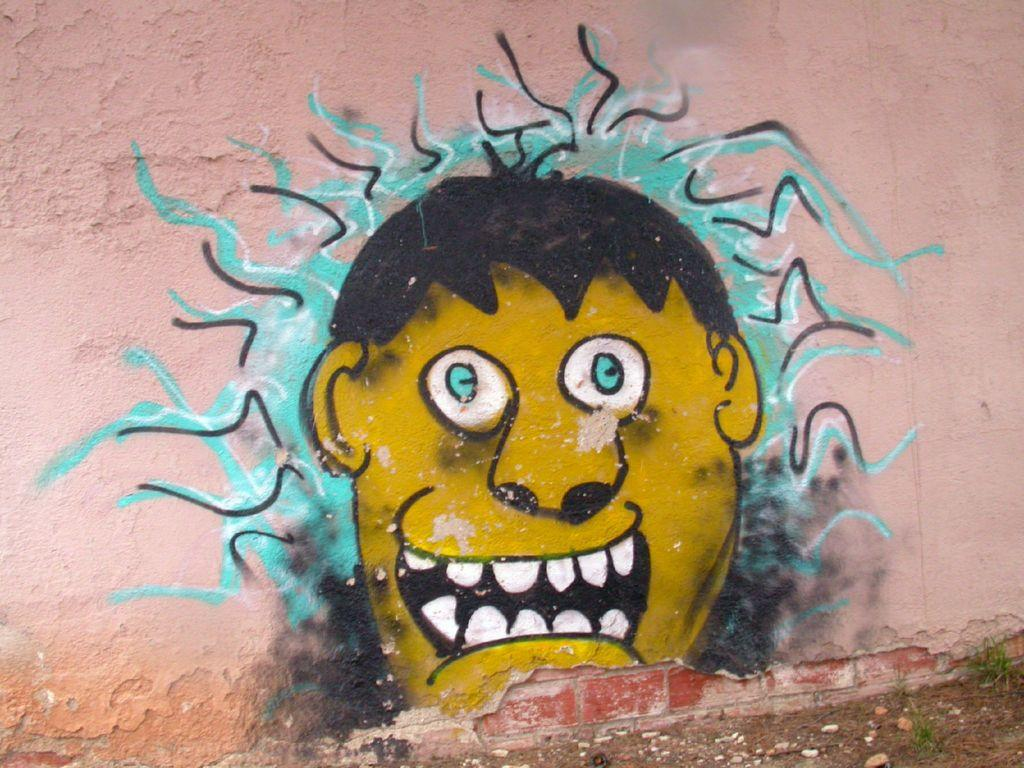What is present on the wall in the image? There is a painting of a man's face on the wall. Can you describe the painting on the wall? The painting on the wall depicts a man's face. What type of thread is being used by the bee in the image? There is no bee or thread present in the image; it only features a wall with a painting of a man's face. 